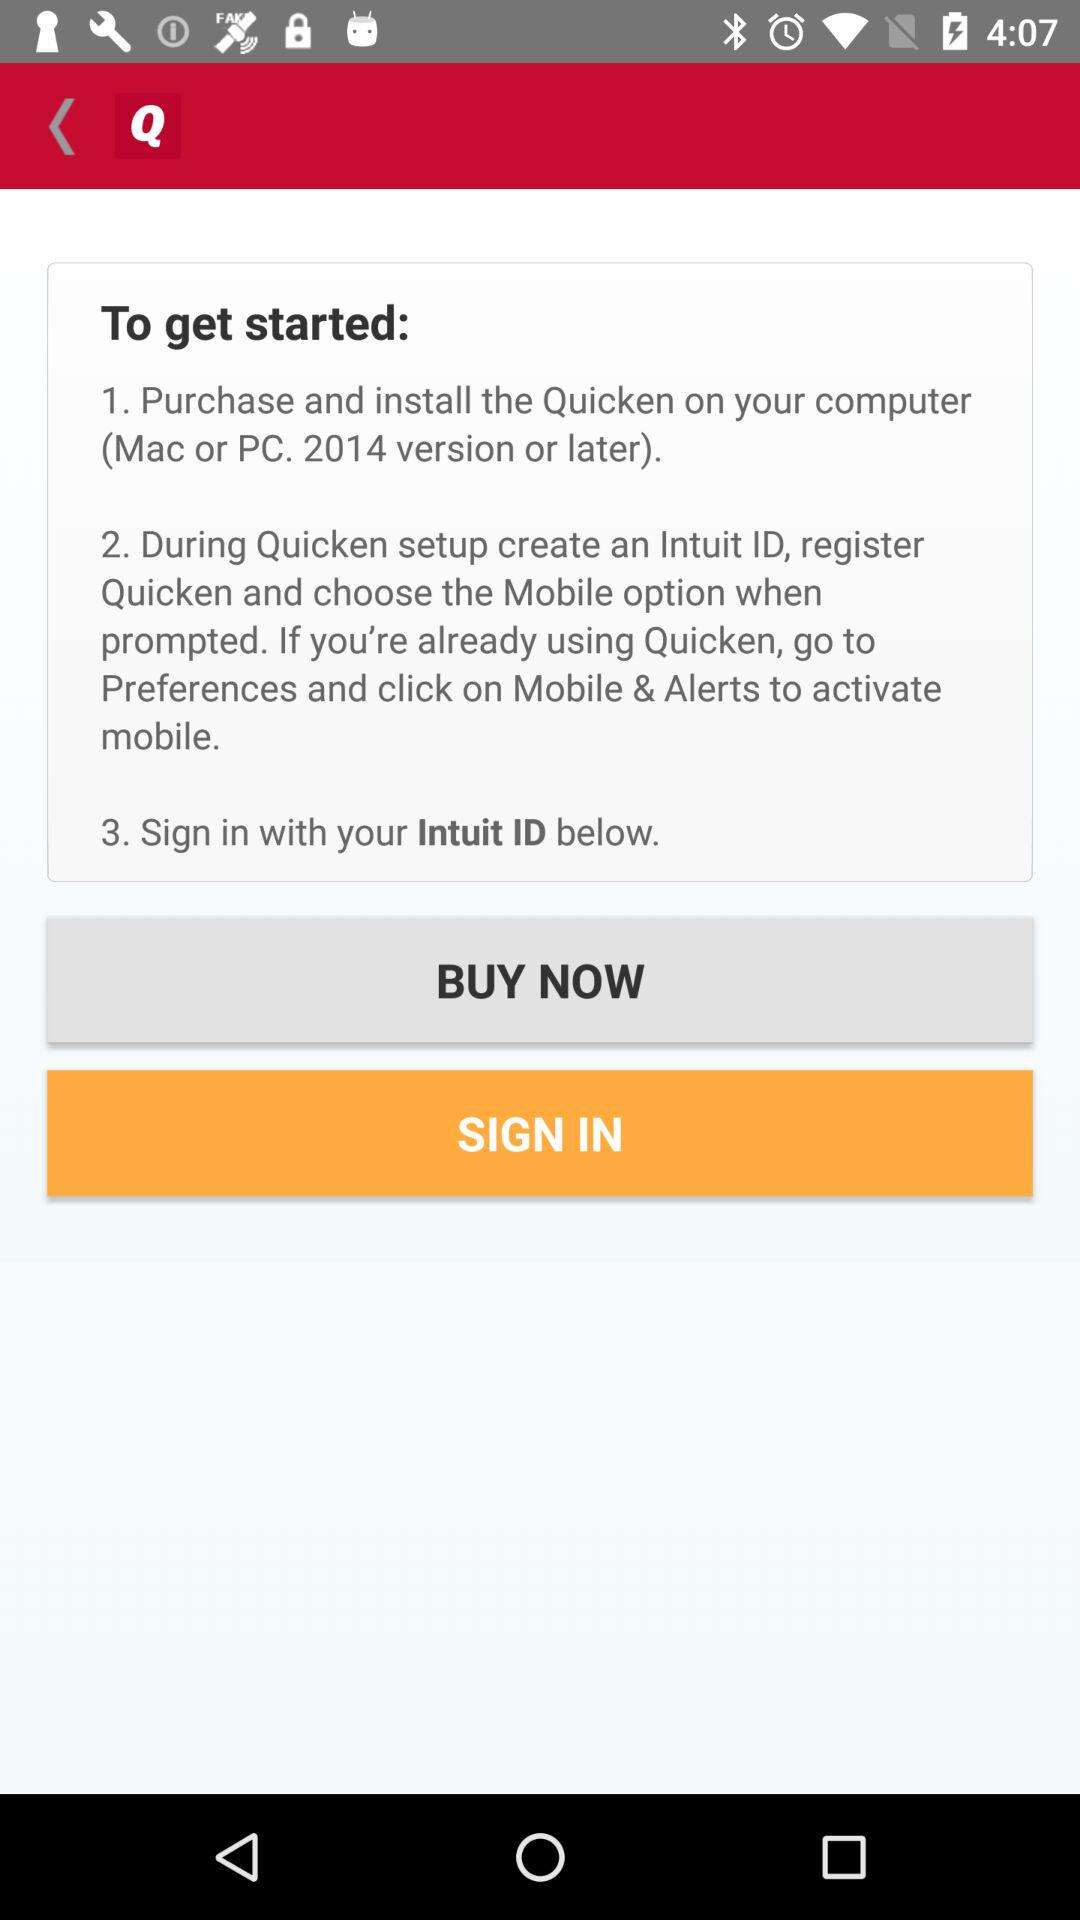How many steps are there in the process?
Answer the question using a single word or phrase. 3 